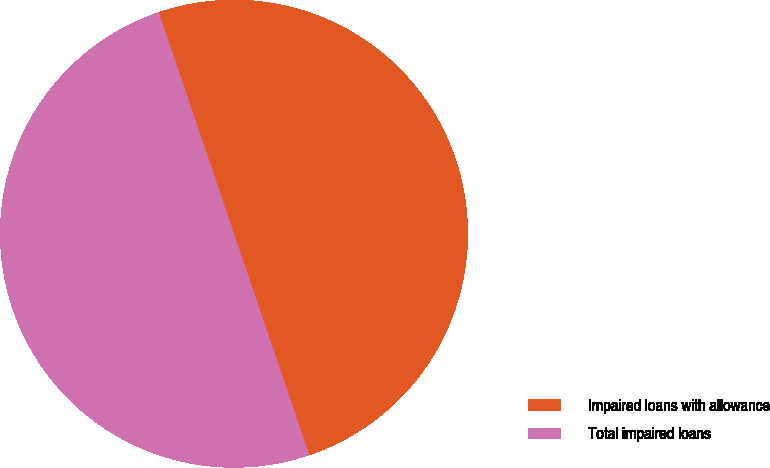<chart> <loc_0><loc_0><loc_500><loc_500><pie_chart><fcel>Impaired loans with allowance<fcel>Total impaired loans<nl><fcel>50.0%<fcel>50.0%<nl></chart> 